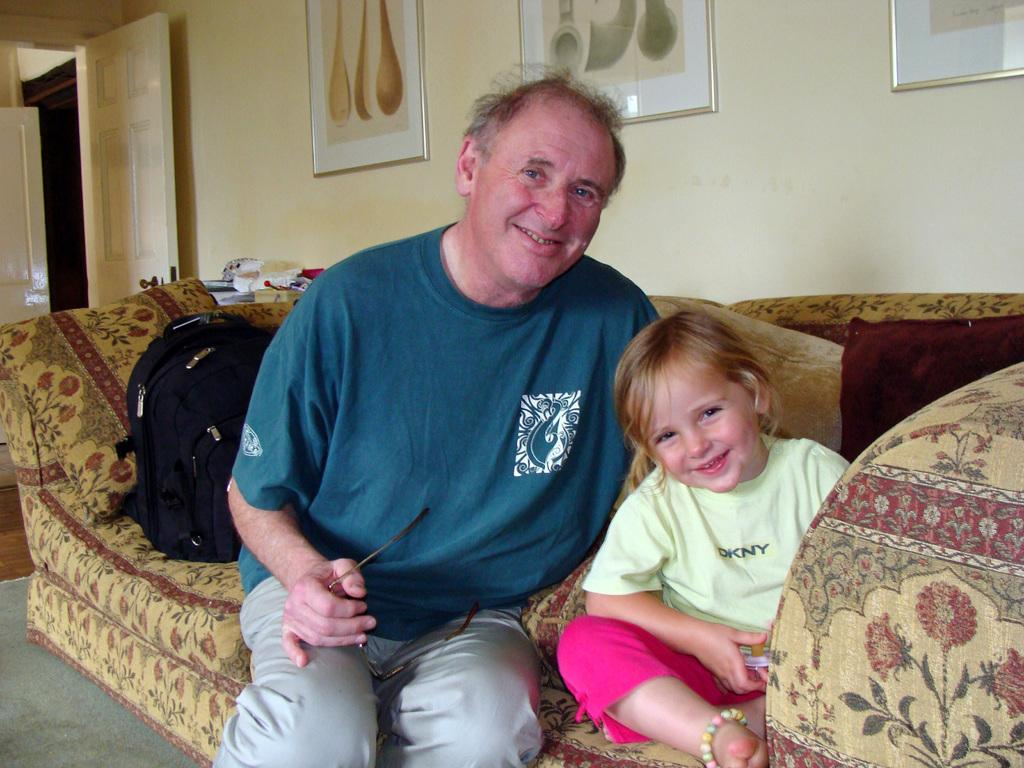Who is present in the image? There is a man and a girl in the image. What is the man holding in his hand? The man is holding spectacles in his hand. Where is the man sitting? The man is sitting on a sofa. How is the girl positioned in relation to the man? The girl is beside the man. What object can be seen in the image that might be used for carrying items? There is a bag in the image. What architectural feature is present in the image? There is a door in the image. What is on the wall in the image? There is a wall with glass frames in the image. What time of day is the man teaching the girl in the image? There is no indication in the image that the man is teaching the girl, nor is there any information about the time of day. How many balls are visible in the image? There are no balls present in the image. 